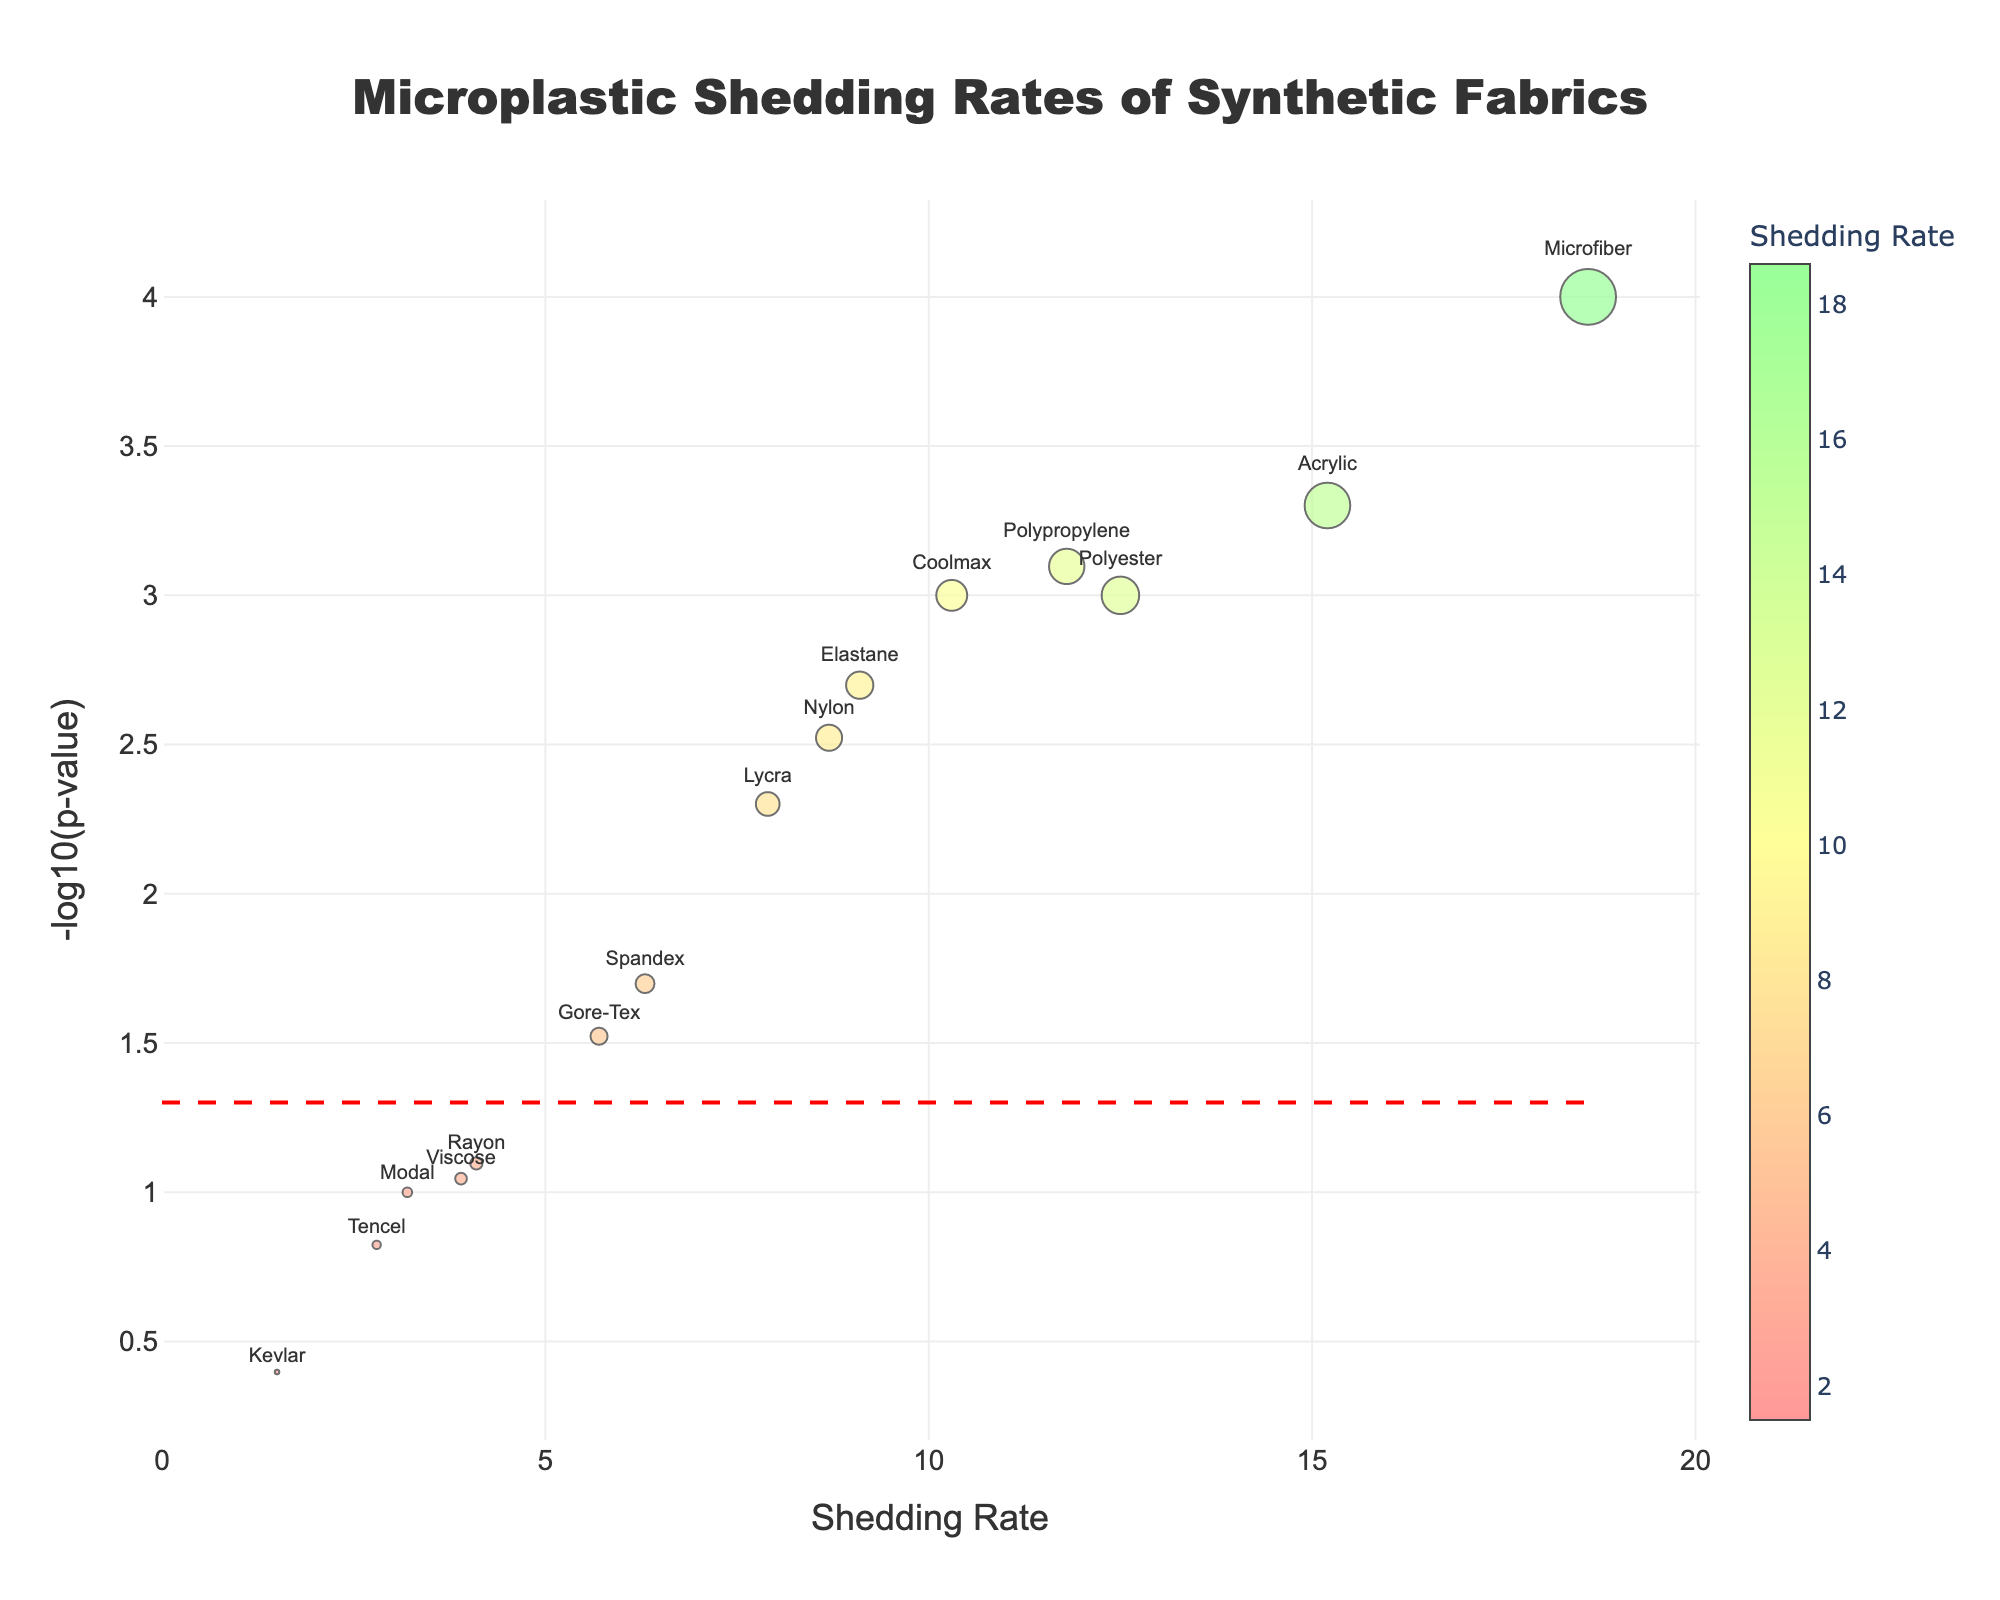what is the title of the plot? The title is usually located at the top of the plot, and it's designed to convey the main subject of the plot. The title here reads "Microplastic Shedding Rates of Synthetic Fabrics".
Answer: Microplastic Shedding Rates of Synthetic Fabrics What is the shedding rate of Acrylic? You can see in the plot that each fabric's shedding rate is specified on the x-axis and cross-referenced with the fabric's name labeled near the data point. The shedding rate for Acrylic appears at 15.2 units.
Answer: 15.2 Which fabric has the highest shedding rate? By comparing the x-axis values, you can find which data point is farthest to the right. Microfiber has the highest shedding rate at 18.6.
Answer: Microfiber How many fabrics have a significance value less than 0.01? By checking the y-axis, which represents -log10(p-value), a significance value of 0.01 corresponds to -log10(0.01) = 2. The fabrics rising above the 2 mark are Polyester, Nylon, Acrylic, Lycra, Microfiber, Coolmax, Polypropylene, and Elastane, totaling 8 fabrics.
Answer: 8 Is the shedding rate of Lycra higher or lower than that of Kevlar? Comparing the x-axis positions of Lycra and Kevlar, you can see that Lycra’s shedding rate (7.9) is higher than that of Kevlar (1.5).
Answer: Higher Which has a lower significance, Rayon or Gore-Tex? On the y-axis, you find that Gore-Tex has a significance level of -log10(0.03) which is higher than Rayon's significance level of -log10(0.08). Thus, Rayon has a lower significance.
Answer: Rayon Which fabric is just above the 0.05 p-value threshold? The line representing the significance threshold corresponds to -log10(0.05). The fabric just above this line is Spandex (6.3, 0.02).
Answer: Spandex What is the approximate -log10(p-value) of Microfiber? To determine -log10(p-value) of Microfiber, locate its y-axis value point. Microfiber's data appears near the 4 mark.
Answer: 4 Considering Acrylic and Nylon, which one has a higher shedding rate, and by how much? Comparatively checking the x-axis values, Acrylic has a shedding rate of 15.2 while Nylon has 8.7. The difference is calculated as 15.2 - 8.7 = 6.5.
Answer: Acrylic by 6.5 For fabrics with significance values below 0.01, what is their average shedding rate? Identifying the fabrics below the 0.01 threshold, their shedding rates are Polyester (12.5), Nylon (8.7), Acrylic (15.2), Lycra (7.9), Microfiber (18.6), Coolmax (10.3), Polypropylene (11.8), and Elastane (9.1). Adding these gives 94.1. The average is 94.1/8 = 11.76.
Answer: 11.76 